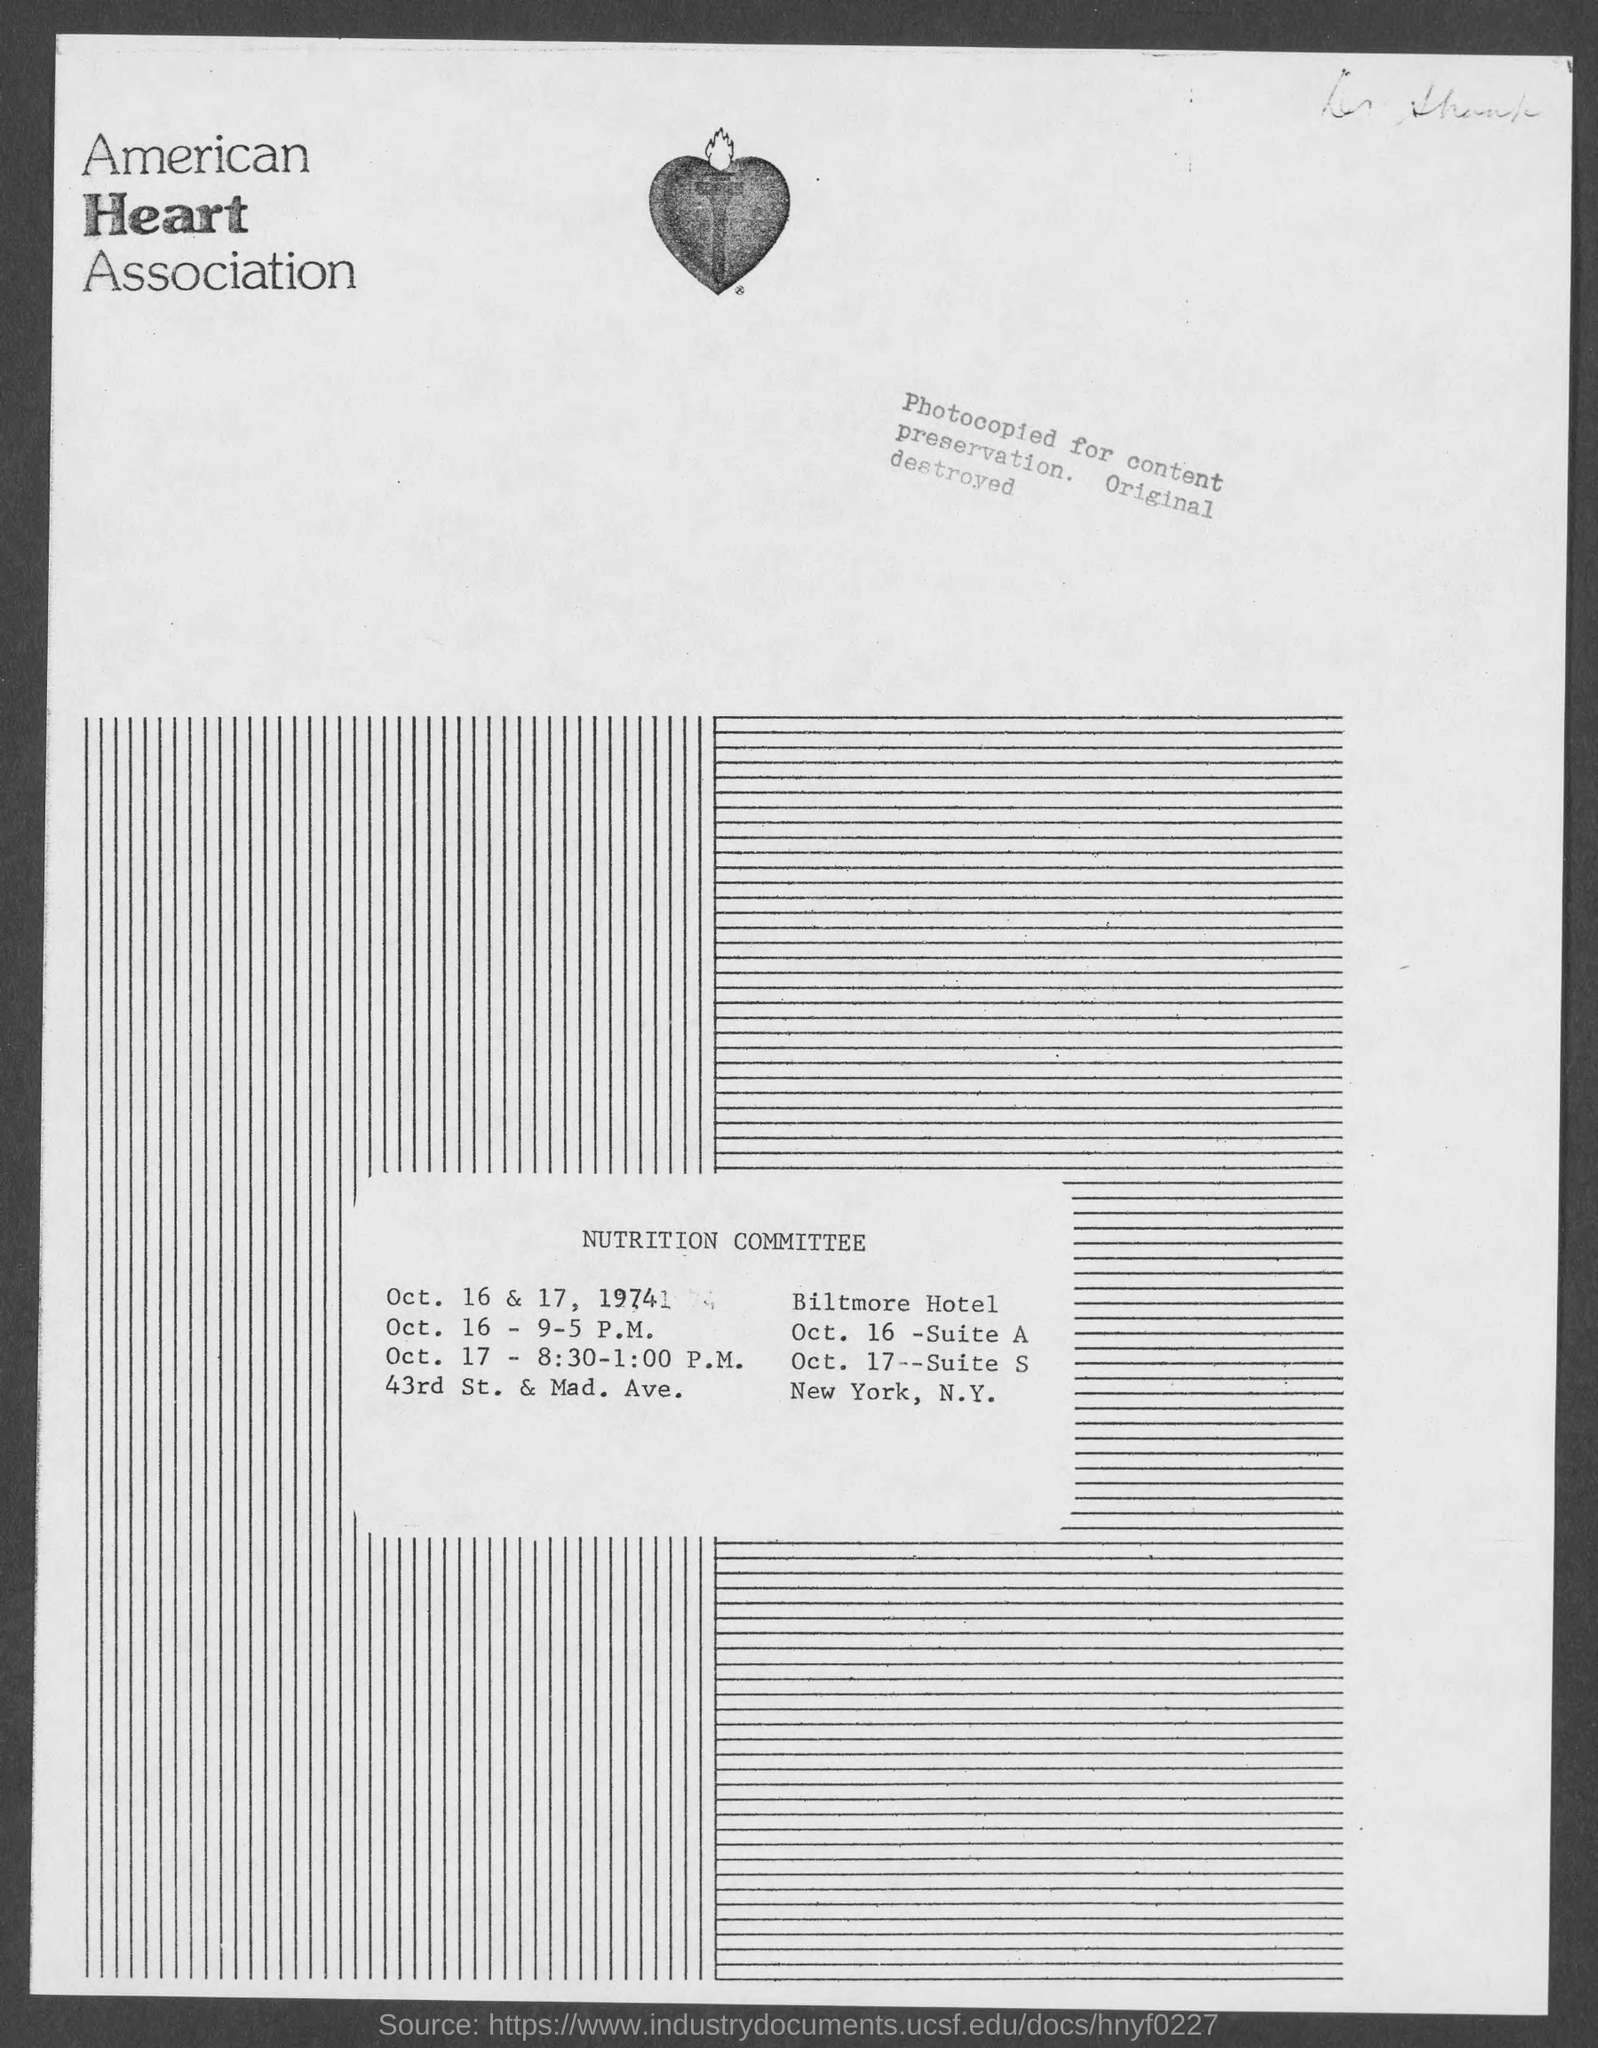What is the name of association?
Provide a short and direct response. American Heart Association. 